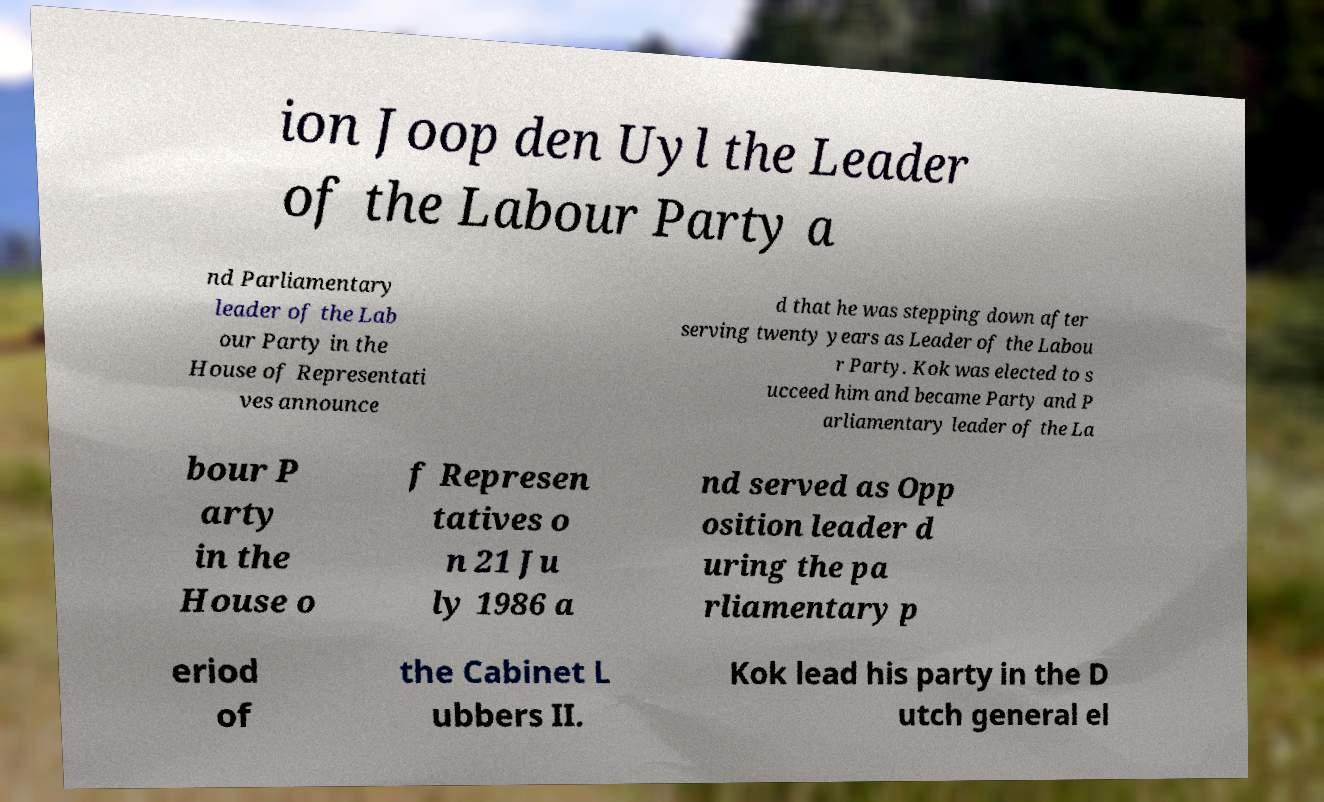Could you assist in decoding the text presented in this image and type it out clearly? ion Joop den Uyl the Leader of the Labour Party a nd Parliamentary leader of the Lab our Party in the House of Representati ves announce d that he was stepping down after serving twenty years as Leader of the Labou r Party. Kok was elected to s ucceed him and became Party and P arliamentary leader of the La bour P arty in the House o f Represen tatives o n 21 Ju ly 1986 a nd served as Opp osition leader d uring the pa rliamentary p eriod of the Cabinet L ubbers II. Kok lead his party in the D utch general el 